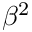Convert formula to latex. <formula><loc_0><loc_0><loc_500><loc_500>\beta ^ { 2 }</formula> 